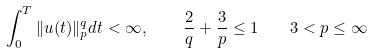<formula> <loc_0><loc_0><loc_500><loc_500>\int _ { 0 } ^ { T } \| u ( t ) \| ^ { q } _ { p } d t < \infty , \quad \, \frac { 2 } { q } + \frac { 3 } { p } \leq 1 \quad 3 < p \leq \infty</formula> 